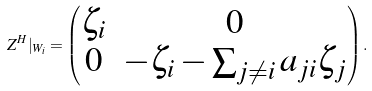<formula> <loc_0><loc_0><loc_500><loc_500>Z ^ { H } | _ { W _ { i } } = \begin{pmatrix} \zeta _ { i } & 0 \\ 0 & - \zeta _ { i } - \sum _ { j \neq i } { a _ { j i } } \zeta _ { j } \end{pmatrix} .</formula> 